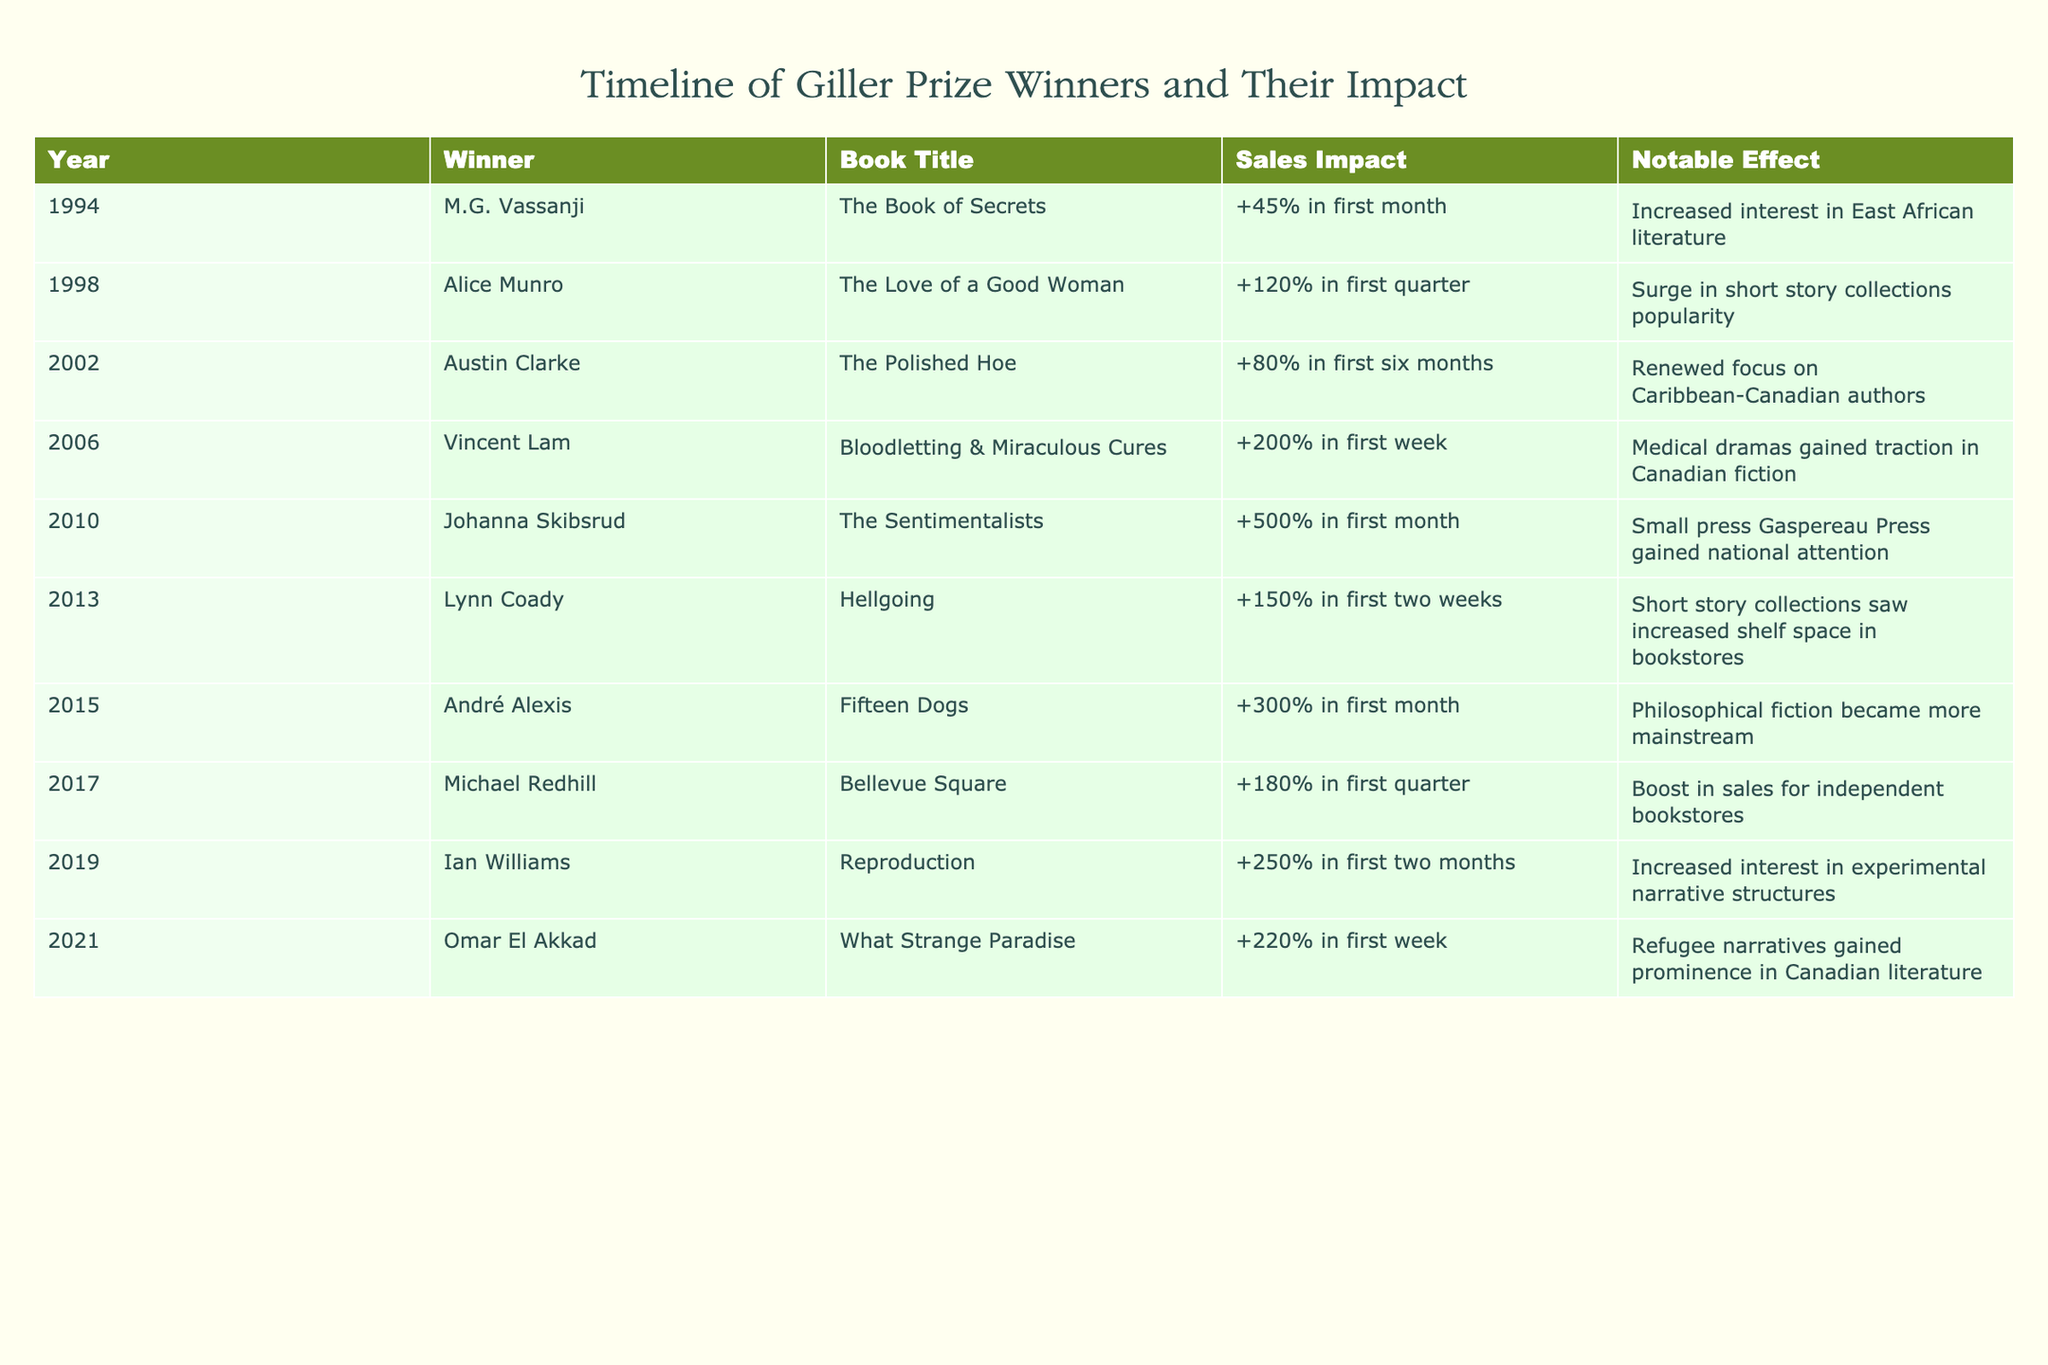What was the sales impact of Johanna Skibsrud's winning book? Johanna Skibsrud won the Giller Prize in 2010 for "The Sentimentalists," which had a sales impact of +500% in the first month.
Answer: +500% Which book had the highest sales impact in the first month? The book with the highest sales impact in the first month is "The Sentimentalists" by Johanna Skibsrud, with an increase of +500%.
Answer: The Sentimentalists Did any Giller Prize winner's book increase interest in Caribbean-Canadian authors? Yes, Austin Clarke's book "The Polished Hoe," which won in 2002, resulted in a renewed focus on Caribbean-Canadian authors.
Answer: Yes What is the average sales impact of the books listed in the table for those winning after 2010? The winners after 2010 include Johanna Skibsrud (+500%), Lynn Coady (+150%), André Alexis (+300%), Michael Redhill (+180%), Ian Williams (+250%), and Omar El Akkad (+220%). To find the average, we add these impacts: 500 + 150 + 300 + 180 + 250 + 220 = 1600, then divide by 6 to get an average of 266.67.
Answer: 266.67 Which year saw a significant increase in the popularity of short story collections? The year 2013 saw a significant increase in the popularity of short story collections when Lynn Coady won for "Hellgoing," which had a sales impact of +150% in the first two weeks.
Answer: 2013 